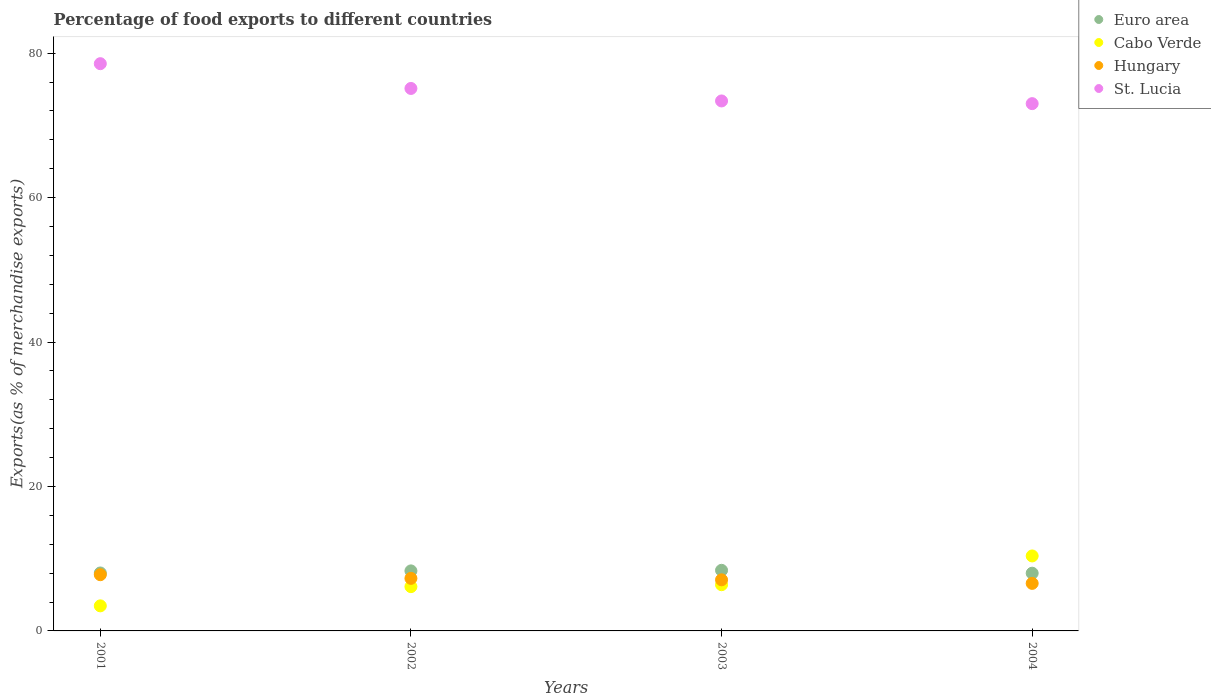What is the percentage of exports to different countries in Cabo Verde in 2003?
Your answer should be very brief. 6.4. Across all years, what is the maximum percentage of exports to different countries in St. Lucia?
Your response must be concise. 78.55. Across all years, what is the minimum percentage of exports to different countries in Hungary?
Keep it short and to the point. 6.58. In which year was the percentage of exports to different countries in St. Lucia maximum?
Your response must be concise. 2001. What is the total percentage of exports to different countries in St. Lucia in the graph?
Your response must be concise. 300.08. What is the difference between the percentage of exports to different countries in St. Lucia in 2003 and that in 2004?
Make the answer very short. 0.37. What is the difference between the percentage of exports to different countries in St. Lucia in 2004 and the percentage of exports to different countries in Cabo Verde in 2002?
Provide a short and direct response. 66.89. What is the average percentage of exports to different countries in Hungary per year?
Keep it short and to the point. 7.18. In the year 2003, what is the difference between the percentage of exports to different countries in St. Lucia and percentage of exports to different countries in Cabo Verde?
Your response must be concise. 66.99. In how many years, is the percentage of exports to different countries in Cabo Verde greater than 72 %?
Keep it short and to the point. 0. What is the ratio of the percentage of exports to different countries in Hungary in 2001 to that in 2004?
Provide a succinct answer. 1.18. Is the percentage of exports to different countries in St. Lucia in 2003 less than that in 2004?
Ensure brevity in your answer.  No. Is the difference between the percentage of exports to different countries in St. Lucia in 2001 and 2003 greater than the difference between the percentage of exports to different countries in Cabo Verde in 2001 and 2003?
Ensure brevity in your answer.  Yes. What is the difference between the highest and the second highest percentage of exports to different countries in Cabo Verde?
Your response must be concise. 3.98. What is the difference between the highest and the lowest percentage of exports to different countries in Hungary?
Your answer should be compact. 1.2. In how many years, is the percentage of exports to different countries in St. Lucia greater than the average percentage of exports to different countries in St. Lucia taken over all years?
Your answer should be compact. 2. Is the sum of the percentage of exports to different countries in Hungary in 2003 and 2004 greater than the maximum percentage of exports to different countries in Cabo Verde across all years?
Offer a terse response. Yes. Is the percentage of exports to different countries in Hungary strictly greater than the percentage of exports to different countries in Cabo Verde over the years?
Your response must be concise. No. Is the percentage of exports to different countries in Cabo Verde strictly less than the percentage of exports to different countries in Hungary over the years?
Your response must be concise. No. How many dotlines are there?
Make the answer very short. 4. Does the graph contain any zero values?
Give a very brief answer. No. Does the graph contain grids?
Keep it short and to the point. No. Where does the legend appear in the graph?
Provide a short and direct response. Top right. How are the legend labels stacked?
Make the answer very short. Vertical. What is the title of the graph?
Provide a succinct answer. Percentage of food exports to different countries. Does "Nepal" appear as one of the legend labels in the graph?
Your answer should be very brief. No. What is the label or title of the Y-axis?
Keep it short and to the point. Exports(as % of merchandise exports). What is the Exports(as % of merchandise exports) of Euro area in 2001?
Give a very brief answer. 8.02. What is the Exports(as % of merchandise exports) in Cabo Verde in 2001?
Ensure brevity in your answer.  3.47. What is the Exports(as % of merchandise exports) of Hungary in 2001?
Provide a short and direct response. 7.78. What is the Exports(as % of merchandise exports) in St. Lucia in 2001?
Keep it short and to the point. 78.55. What is the Exports(as % of merchandise exports) in Euro area in 2002?
Provide a short and direct response. 8.31. What is the Exports(as % of merchandise exports) in Cabo Verde in 2002?
Give a very brief answer. 6.13. What is the Exports(as % of merchandise exports) in Hungary in 2002?
Give a very brief answer. 7.28. What is the Exports(as % of merchandise exports) of St. Lucia in 2002?
Your answer should be very brief. 75.12. What is the Exports(as % of merchandise exports) in Euro area in 2003?
Your response must be concise. 8.39. What is the Exports(as % of merchandise exports) in Cabo Verde in 2003?
Give a very brief answer. 6.4. What is the Exports(as % of merchandise exports) in Hungary in 2003?
Offer a very short reply. 7.08. What is the Exports(as % of merchandise exports) in St. Lucia in 2003?
Provide a short and direct response. 73.39. What is the Exports(as % of merchandise exports) in Euro area in 2004?
Give a very brief answer. 7.99. What is the Exports(as % of merchandise exports) of Cabo Verde in 2004?
Offer a terse response. 10.38. What is the Exports(as % of merchandise exports) in Hungary in 2004?
Your answer should be compact. 6.58. What is the Exports(as % of merchandise exports) of St. Lucia in 2004?
Provide a succinct answer. 73.02. Across all years, what is the maximum Exports(as % of merchandise exports) of Euro area?
Offer a very short reply. 8.39. Across all years, what is the maximum Exports(as % of merchandise exports) in Cabo Verde?
Make the answer very short. 10.38. Across all years, what is the maximum Exports(as % of merchandise exports) in Hungary?
Offer a terse response. 7.78. Across all years, what is the maximum Exports(as % of merchandise exports) in St. Lucia?
Ensure brevity in your answer.  78.55. Across all years, what is the minimum Exports(as % of merchandise exports) of Euro area?
Your answer should be very brief. 7.99. Across all years, what is the minimum Exports(as % of merchandise exports) in Cabo Verde?
Keep it short and to the point. 3.47. Across all years, what is the minimum Exports(as % of merchandise exports) of Hungary?
Your answer should be very brief. 6.58. Across all years, what is the minimum Exports(as % of merchandise exports) in St. Lucia?
Provide a short and direct response. 73.02. What is the total Exports(as % of merchandise exports) in Euro area in the graph?
Ensure brevity in your answer.  32.72. What is the total Exports(as % of merchandise exports) in Cabo Verde in the graph?
Offer a very short reply. 26.38. What is the total Exports(as % of merchandise exports) of Hungary in the graph?
Your answer should be very brief. 28.72. What is the total Exports(as % of merchandise exports) of St. Lucia in the graph?
Ensure brevity in your answer.  300.08. What is the difference between the Exports(as % of merchandise exports) of Euro area in 2001 and that in 2002?
Keep it short and to the point. -0.29. What is the difference between the Exports(as % of merchandise exports) of Cabo Verde in 2001 and that in 2002?
Keep it short and to the point. -2.66. What is the difference between the Exports(as % of merchandise exports) in Hungary in 2001 and that in 2002?
Offer a terse response. 0.51. What is the difference between the Exports(as % of merchandise exports) in St. Lucia in 2001 and that in 2002?
Your answer should be very brief. 3.43. What is the difference between the Exports(as % of merchandise exports) in Euro area in 2001 and that in 2003?
Keep it short and to the point. -0.37. What is the difference between the Exports(as % of merchandise exports) of Cabo Verde in 2001 and that in 2003?
Offer a very short reply. -2.93. What is the difference between the Exports(as % of merchandise exports) in Hungary in 2001 and that in 2003?
Offer a very short reply. 0.71. What is the difference between the Exports(as % of merchandise exports) of St. Lucia in 2001 and that in 2003?
Make the answer very short. 5.16. What is the difference between the Exports(as % of merchandise exports) of Euro area in 2001 and that in 2004?
Provide a succinct answer. 0.03. What is the difference between the Exports(as % of merchandise exports) of Cabo Verde in 2001 and that in 2004?
Offer a terse response. -6.91. What is the difference between the Exports(as % of merchandise exports) in Hungary in 2001 and that in 2004?
Offer a terse response. 1.2. What is the difference between the Exports(as % of merchandise exports) of St. Lucia in 2001 and that in 2004?
Provide a short and direct response. 5.53. What is the difference between the Exports(as % of merchandise exports) in Euro area in 2002 and that in 2003?
Provide a succinct answer. -0.08. What is the difference between the Exports(as % of merchandise exports) in Cabo Verde in 2002 and that in 2003?
Ensure brevity in your answer.  -0.27. What is the difference between the Exports(as % of merchandise exports) in Hungary in 2002 and that in 2003?
Provide a short and direct response. 0.2. What is the difference between the Exports(as % of merchandise exports) in St. Lucia in 2002 and that in 2003?
Provide a short and direct response. 1.73. What is the difference between the Exports(as % of merchandise exports) in Euro area in 2002 and that in 2004?
Your answer should be very brief. 0.32. What is the difference between the Exports(as % of merchandise exports) of Cabo Verde in 2002 and that in 2004?
Offer a very short reply. -4.25. What is the difference between the Exports(as % of merchandise exports) in Hungary in 2002 and that in 2004?
Provide a short and direct response. 0.69. What is the difference between the Exports(as % of merchandise exports) of St. Lucia in 2002 and that in 2004?
Offer a very short reply. 2.1. What is the difference between the Exports(as % of merchandise exports) of Cabo Verde in 2003 and that in 2004?
Ensure brevity in your answer.  -3.98. What is the difference between the Exports(as % of merchandise exports) in Hungary in 2003 and that in 2004?
Offer a very short reply. 0.49. What is the difference between the Exports(as % of merchandise exports) of St. Lucia in 2003 and that in 2004?
Provide a succinct answer. 0.37. What is the difference between the Exports(as % of merchandise exports) of Euro area in 2001 and the Exports(as % of merchandise exports) of Cabo Verde in 2002?
Make the answer very short. 1.89. What is the difference between the Exports(as % of merchandise exports) of Euro area in 2001 and the Exports(as % of merchandise exports) of Hungary in 2002?
Provide a succinct answer. 0.75. What is the difference between the Exports(as % of merchandise exports) in Euro area in 2001 and the Exports(as % of merchandise exports) in St. Lucia in 2002?
Keep it short and to the point. -67.1. What is the difference between the Exports(as % of merchandise exports) of Cabo Verde in 2001 and the Exports(as % of merchandise exports) of Hungary in 2002?
Offer a very short reply. -3.81. What is the difference between the Exports(as % of merchandise exports) in Cabo Verde in 2001 and the Exports(as % of merchandise exports) in St. Lucia in 2002?
Offer a terse response. -71.65. What is the difference between the Exports(as % of merchandise exports) in Hungary in 2001 and the Exports(as % of merchandise exports) in St. Lucia in 2002?
Provide a succinct answer. -67.34. What is the difference between the Exports(as % of merchandise exports) of Euro area in 2001 and the Exports(as % of merchandise exports) of Cabo Verde in 2003?
Your answer should be very brief. 1.62. What is the difference between the Exports(as % of merchandise exports) in Euro area in 2001 and the Exports(as % of merchandise exports) in Hungary in 2003?
Provide a succinct answer. 0.95. What is the difference between the Exports(as % of merchandise exports) of Euro area in 2001 and the Exports(as % of merchandise exports) of St. Lucia in 2003?
Your answer should be very brief. -65.37. What is the difference between the Exports(as % of merchandise exports) of Cabo Verde in 2001 and the Exports(as % of merchandise exports) of Hungary in 2003?
Offer a terse response. -3.61. What is the difference between the Exports(as % of merchandise exports) of Cabo Verde in 2001 and the Exports(as % of merchandise exports) of St. Lucia in 2003?
Make the answer very short. -69.92. What is the difference between the Exports(as % of merchandise exports) of Hungary in 2001 and the Exports(as % of merchandise exports) of St. Lucia in 2003?
Your answer should be very brief. -65.61. What is the difference between the Exports(as % of merchandise exports) in Euro area in 2001 and the Exports(as % of merchandise exports) in Cabo Verde in 2004?
Your response must be concise. -2.36. What is the difference between the Exports(as % of merchandise exports) in Euro area in 2001 and the Exports(as % of merchandise exports) in Hungary in 2004?
Your response must be concise. 1.44. What is the difference between the Exports(as % of merchandise exports) of Euro area in 2001 and the Exports(as % of merchandise exports) of St. Lucia in 2004?
Offer a terse response. -64.99. What is the difference between the Exports(as % of merchandise exports) of Cabo Verde in 2001 and the Exports(as % of merchandise exports) of Hungary in 2004?
Your answer should be compact. -3.11. What is the difference between the Exports(as % of merchandise exports) of Cabo Verde in 2001 and the Exports(as % of merchandise exports) of St. Lucia in 2004?
Offer a very short reply. -69.55. What is the difference between the Exports(as % of merchandise exports) in Hungary in 2001 and the Exports(as % of merchandise exports) in St. Lucia in 2004?
Your answer should be very brief. -65.23. What is the difference between the Exports(as % of merchandise exports) in Euro area in 2002 and the Exports(as % of merchandise exports) in Cabo Verde in 2003?
Your answer should be compact. 1.91. What is the difference between the Exports(as % of merchandise exports) in Euro area in 2002 and the Exports(as % of merchandise exports) in Hungary in 2003?
Keep it short and to the point. 1.23. What is the difference between the Exports(as % of merchandise exports) in Euro area in 2002 and the Exports(as % of merchandise exports) in St. Lucia in 2003?
Offer a very short reply. -65.08. What is the difference between the Exports(as % of merchandise exports) in Cabo Verde in 2002 and the Exports(as % of merchandise exports) in Hungary in 2003?
Your response must be concise. -0.95. What is the difference between the Exports(as % of merchandise exports) of Cabo Verde in 2002 and the Exports(as % of merchandise exports) of St. Lucia in 2003?
Provide a succinct answer. -67.26. What is the difference between the Exports(as % of merchandise exports) in Hungary in 2002 and the Exports(as % of merchandise exports) in St. Lucia in 2003?
Your response must be concise. -66.11. What is the difference between the Exports(as % of merchandise exports) in Euro area in 2002 and the Exports(as % of merchandise exports) in Cabo Verde in 2004?
Your answer should be compact. -2.07. What is the difference between the Exports(as % of merchandise exports) of Euro area in 2002 and the Exports(as % of merchandise exports) of Hungary in 2004?
Your answer should be very brief. 1.73. What is the difference between the Exports(as % of merchandise exports) in Euro area in 2002 and the Exports(as % of merchandise exports) in St. Lucia in 2004?
Give a very brief answer. -64.71. What is the difference between the Exports(as % of merchandise exports) of Cabo Verde in 2002 and the Exports(as % of merchandise exports) of Hungary in 2004?
Make the answer very short. -0.45. What is the difference between the Exports(as % of merchandise exports) of Cabo Verde in 2002 and the Exports(as % of merchandise exports) of St. Lucia in 2004?
Keep it short and to the point. -66.89. What is the difference between the Exports(as % of merchandise exports) in Hungary in 2002 and the Exports(as % of merchandise exports) in St. Lucia in 2004?
Give a very brief answer. -65.74. What is the difference between the Exports(as % of merchandise exports) in Euro area in 2003 and the Exports(as % of merchandise exports) in Cabo Verde in 2004?
Offer a terse response. -1.99. What is the difference between the Exports(as % of merchandise exports) of Euro area in 2003 and the Exports(as % of merchandise exports) of Hungary in 2004?
Provide a short and direct response. 1.81. What is the difference between the Exports(as % of merchandise exports) in Euro area in 2003 and the Exports(as % of merchandise exports) in St. Lucia in 2004?
Your answer should be very brief. -64.63. What is the difference between the Exports(as % of merchandise exports) in Cabo Verde in 2003 and the Exports(as % of merchandise exports) in Hungary in 2004?
Ensure brevity in your answer.  -0.18. What is the difference between the Exports(as % of merchandise exports) of Cabo Verde in 2003 and the Exports(as % of merchandise exports) of St. Lucia in 2004?
Offer a very short reply. -66.62. What is the difference between the Exports(as % of merchandise exports) in Hungary in 2003 and the Exports(as % of merchandise exports) in St. Lucia in 2004?
Keep it short and to the point. -65.94. What is the average Exports(as % of merchandise exports) in Euro area per year?
Provide a succinct answer. 8.18. What is the average Exports(as % of merchandise exports) of Cabo Verde per year?
Make the answer very short. 6.6. What is the average Exports(as % of merchandise exports) in Hungary per year?
Ensure brevity in your answer.  7.18. What is the average Exports(as % of merchandise exports) in St. Lucia per year?
Your response must be concise. 75.02. In the year 2001, what is the difference between the Exports(as % of merchandise exports) of Euro area and Exports(as % of merchandise exports) of Cabo Verde?
Make the answer very short. 4.55. In the year 2001, what is the difference between the Exports(as % of merchandise exports) of Euro area and Exports(as % of merchandise exports) of Hungary?
Give a very brief answer. 0.24. In the year 2001, what is the difference between the Exports(as % of merchandise exports) of Euro area and Exports(as % of merchandise exports) of St. Lucia?
Your answer should be very brief. -70.53. In the year 2001, what is the difference between the Exports(as % of merchandise exports) in Cabo Verde and Exports(as % of merchandise exports) in Hungary?
Give a very brief answer. -4.31. In the year 2001, what is the difference between the Exports(as % of merchandise exports) in Cabo Verde and Exports(as % of merchandise exports) in St. Lucia?
Your response must be concise. -75.08. In the year 2001, what is the difference between the Exports(as % of merchandise exports) in Hungary and Exports(as % of merchandise exports) in St. Lucia?
Your answer should be very brief. -70.77. In the year 2002, what is the difference between the Exports(as % of merchandise exports) in Euro area and Exports(as % of merchandise exports) in Cabo Verde?
Your response must be concise. 2.18. In the year 2002, what is the difference between the Exports(as % of merchandise exports) of Euro area and Exports(as % of merchandise exports) of Hungary?
Provide a short and direct response. 1.03. In the year 2002, what is the difference between the Exports(as % of merchandise exports) of Euro area and Exports(as % of merchandise exports) of St. Lucia?
Give a very brief answer. -66.81. In the year 2002, what is the difference between the Exports(as % of merchandise exports) in Cabo Verde and Exports(as % of merchandise exports) in Hungary?
Make the answer very short. -1.15. In the year 2002, what is the difference between the Exports(as % of merchandise exports) in Cabo Verde and Exports(as % of merchandise exports) in St. Lucia?
Give a very brief answer. -68.99. In the year 2002, what is the difference between the Exports(as % of merchandise exports) in Hungary and Exports(as % of merchandise exports) in St. Lucia?
Give a very brief answer. -67.84. In the year 2003, what is the difference between the Exports(as % of merchandise exports) in Euro area and Exports(as % of merchandise exports) in Cabo Verde?
Make the answer very short. 1.99. In the year 2003, what is the difference between the Exports(as % of merchandise exports) in Euro area and Exports(as % of merchandise exports) in Hungary?
Make the answer very short. 1.31. In the year 2003, what is the difference between the Exports(as % of merchandise exports) of Euro area and Exports(as % of merchandise exports) of St. Lucia?
Give a very brief answer. -65. In the year 2003, what is the difference between the Exports(as % of merchandise exports) of Cabo Verde and Exports(as % of merchandise exports) of Hungary?
Give a very brief answer. -0.68. In the year 2003, what is the difference between the Exports(as % of merchandise exports) of Cabo Verde and Exports(as % of merchandise exports) of St. Lucia?
Give a very brief answer. -66.99. In the year 2003, what is the difference between the Exports(as % of merchandise exports) of Hungary and Exports(as % of merchandise exports) of St. Lucia?
Provide a succinct answer. -66.31. In the year 2004, what is the difference between the Exports(as % of merchandise exports) in Euro area and Exports(as % of merchandise exports) in Cabo Verde?
Provide a short and direct response. -2.39. In the year 2004, what is the difference between the Exports(as % of merchandise exports) of Euro area and Exports(as % of merchandise exports) of Hungary?
Provide a short and direct response. 1.41. In the year 2004, what is the difference between the Exports(as % of merchandise exports) in Euro area and Exports(as % of merchandise exports) in St. Lucia?
Offer a very short reply. -65.03. In the year 2004, what is the difference between the Exports(as % of merchandise exports) of Cabo Verde and Exports(as % of merchandise exports) of Hungary?
Provide a short and direct response. 3.8. In the year 2004, what is the difference between the Exports(as % of merchandise exports) of Cabo Verde and Exports(as % of merchandise exports) of St. Lucia?
Offer a terse response. -62.63. In the year 2004, what is the difference between the Exports(as % of merchandise exports) of Hungary and Exports(as % of merchandise exports) of St. Lucia?
Keep it short and to the point. -66.43. What is the ratio of the Exports(as % of merchandise exports) of Euro area in 2001 to that in 2002?
Provide a short and direct response. 0.97. What is the ratio of the Exports(as % of merchandise exports) of Cabo Verde in 2001 to that in 2002?
Your answer should be very brief. 0.57. What is the ratio of the Exports(as % of merchandise exports) of Hungary in 2001 to that in 2002?
Provide a succinct answer. 1.07. What is the ratio of the Exports(as % of merchandise exports) of St. Lucia in 2001 to that in 2002?
Make the answer very short. 1.05. What is the ratio of the Exports(as % of merchandise exports) of Euro area in 2001 to that in 2003?
Ensure brevity in your answer.  0.96. What is the ratio of the Exports(as % of merchandise exports) in Cabo Verde in 2001 to that in 2003?
Keep it short and to the point. 0.54. What is the ratio of the Exports(as % of merchandise exports) in Hungary in 2001 to that in 2003?
Offer a very short reply. 1.1. What is the ratio of the Exports(as % of merchandise exports) of St. Lucia in 2001 to that in 2003?
Your answer should be compact. 1.07. What is the ratio of the Exports(as % of merchandise exports) of Euro area in 2001 to that in 2004?
Your answer should be very brief. 1. What is the ratio of the Exports(as % of merchandise exports) of Cabo Verde in 2001 to that in 2004?
Keep it short and to the point. 0.33. What is the ratio of the Exports(as % of merchandise exports) in Hungary in 2001 to that in 2004?
Your response must be concise. 1.18. What is the ratio of the Exports(as % of merchandise exports) in St. Lucia in 2001 to that in 2004?
Offer a very short reply. 1.08. What is the ratio of the Exports(as % of merchandise exports) in Hungary in 2002 to that in 2003?
Make the answer very short. 1.03. What is the ratio of the Exports(as % of merchandise exports) in St. Lucia in 2002 to that in 2003?
Provide a succinct answer. 1.02. What is the ratio of the Exports(as % of merchandise exports) in Cabo Verde in 2002 to that in 2004?
Make the answer very short. 0.59. What is the ratio of the Exports(as % of merchandise exports) of Hungary in 2002 to that in 2004?
Make the answer very short. 1.11. What is the ratio of the Exports(as % of merchandise exports) in St. Lucia in 2002 to that in 2004?
Give a very brief answer. 1.03. What is the ratio of the Exports(as % of merchandise exports) of Cabo Verde in 2003 to that in 2004?
Make the answer very short. 0.62. What is the ratio of the Exports(as % of merchandise exports) of Hungary in 2003 to that in 2004?
Offer a very short reply. 1.08. What is the ratio of the Exports(as % of merchandise exports) in St. Lucia in 2003 to that in 2004?
Your answer should be compact. 1.01. What is the difference between the highest and the second highest Exports(as % of merchandise exports) in Euro area?
Give a very brief answer. 0.08. What is the difference between the highest and the second highest Exports(as % of merchandise exports) of Cabo Verde?
Offer a very short reply. 3.98. What is the difference between the highest and the second highest Exports(as % of merchandise exports) of Hungary?
Keep it short and to the point. 0.51. What is the difference between the highest and the second highest Exports(as % of merchandise exports) of St. Lucia?
Provide a short and direct response. 3.43. What is the difference between the highest and the lowest Exports(as % of merchandise exports) in Euro area?
Make the answer very short. 0.4. What is the difference between the highest and the lowest Exports(as % of merchandise exports) in Cabo Verde?
Provide a short and direct response. 6.91. What is the difference between the highest and the lowest Exports(as % of merchandise exports) in Hungary?
Make the answer very short. 1.2. What is the difference between the highest and the lowest Exports(as % of merchandise exports) of St. Lucia?
Your answer should be compact. 5.53. 